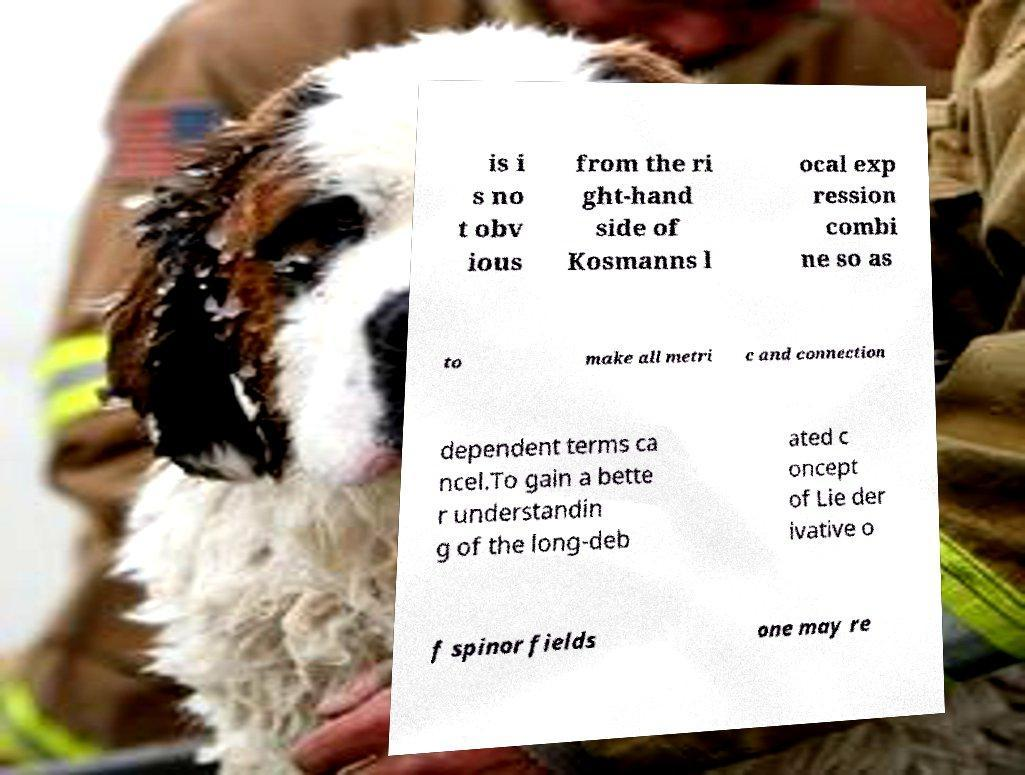Can you accurately transcribe the text from the provided image for me? is i s no t obv ious from the ri ght-hand side of Kosmanns l ocal exp ression combi ne so as to make all metri c and connection dependent terms ca ncel.To gain a bette r understandin g of the long-deb ated c oncept of Lie der ivative o f spinor fields one may re 